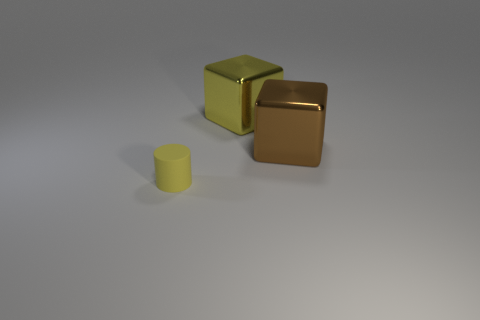Add 3 matte objects. How many objects exist? 6 Subtract all cylinders. How many objects are left? 2 Add 3 yellow cylinders. How many yellow cylinders exist? 4 Subtract 0 yellow balls. How many objects are left? 3 Subtract all small yellow things. Subtract all yellow metallic cubes. How many objects are left? 1 Add 1 small objects. How many small objects are left? 2 